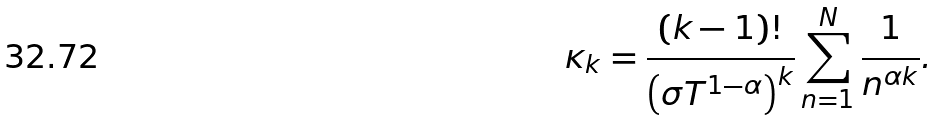<formula> <loc_0><loc_0><loc_500><loc_500>\kappa _ { k } = \frac { ( k - 1 ) ! } { \left ( \sigma T ^ { 1 - \alpha } \right ) ^ { k } } \sum _ { n = 1 } ^ { N } \frac { 1 } { n ^ { \alpha k } } .</formula> 